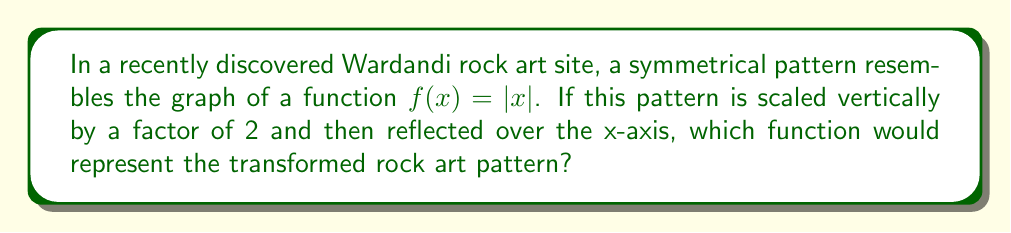Provide a solution to this math problem. Let's approach this step-by-step:

1) The original function is $f(x) = |x|$, which represents the basic V-shaped graph of the absolute value function.

2) The first transformation is a vertical scaling by a factor of 2. This can be represented mathematically as:

   $g(x) = 2f(x) = 2|x|$

3) The second transformation is a reflection over the x-axis. Mathematically, this is achieved by negating the function:

   $h(x) = -g(x) = -2|x|$

4) Therefore, the final transformed function is $h(x) = -2|x|$

This function will look like an inverted V-shape, twice as steep as the original, and pointing downwards instead of upwards.
Answer: $h(x) = -2|x|$ 